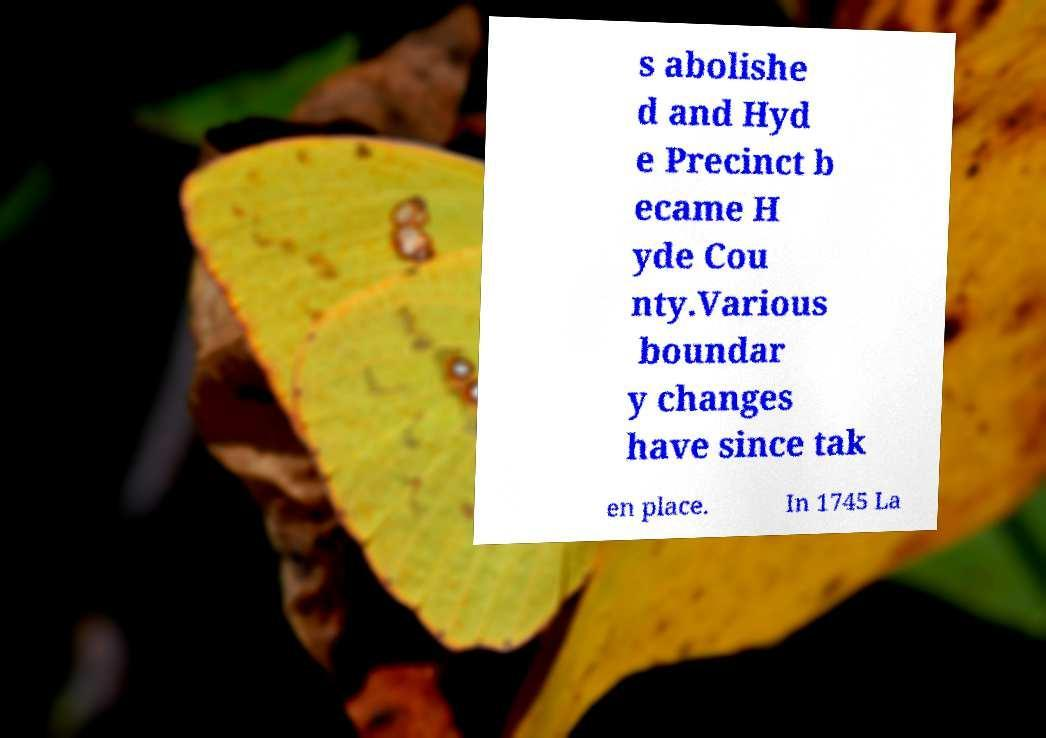Please identify and transcribe the text found in this image. s abolishe d and Hyd e Precinct b ecame H yde Cou nty.Various boundar y changes have since tak en place. In 1745 La 